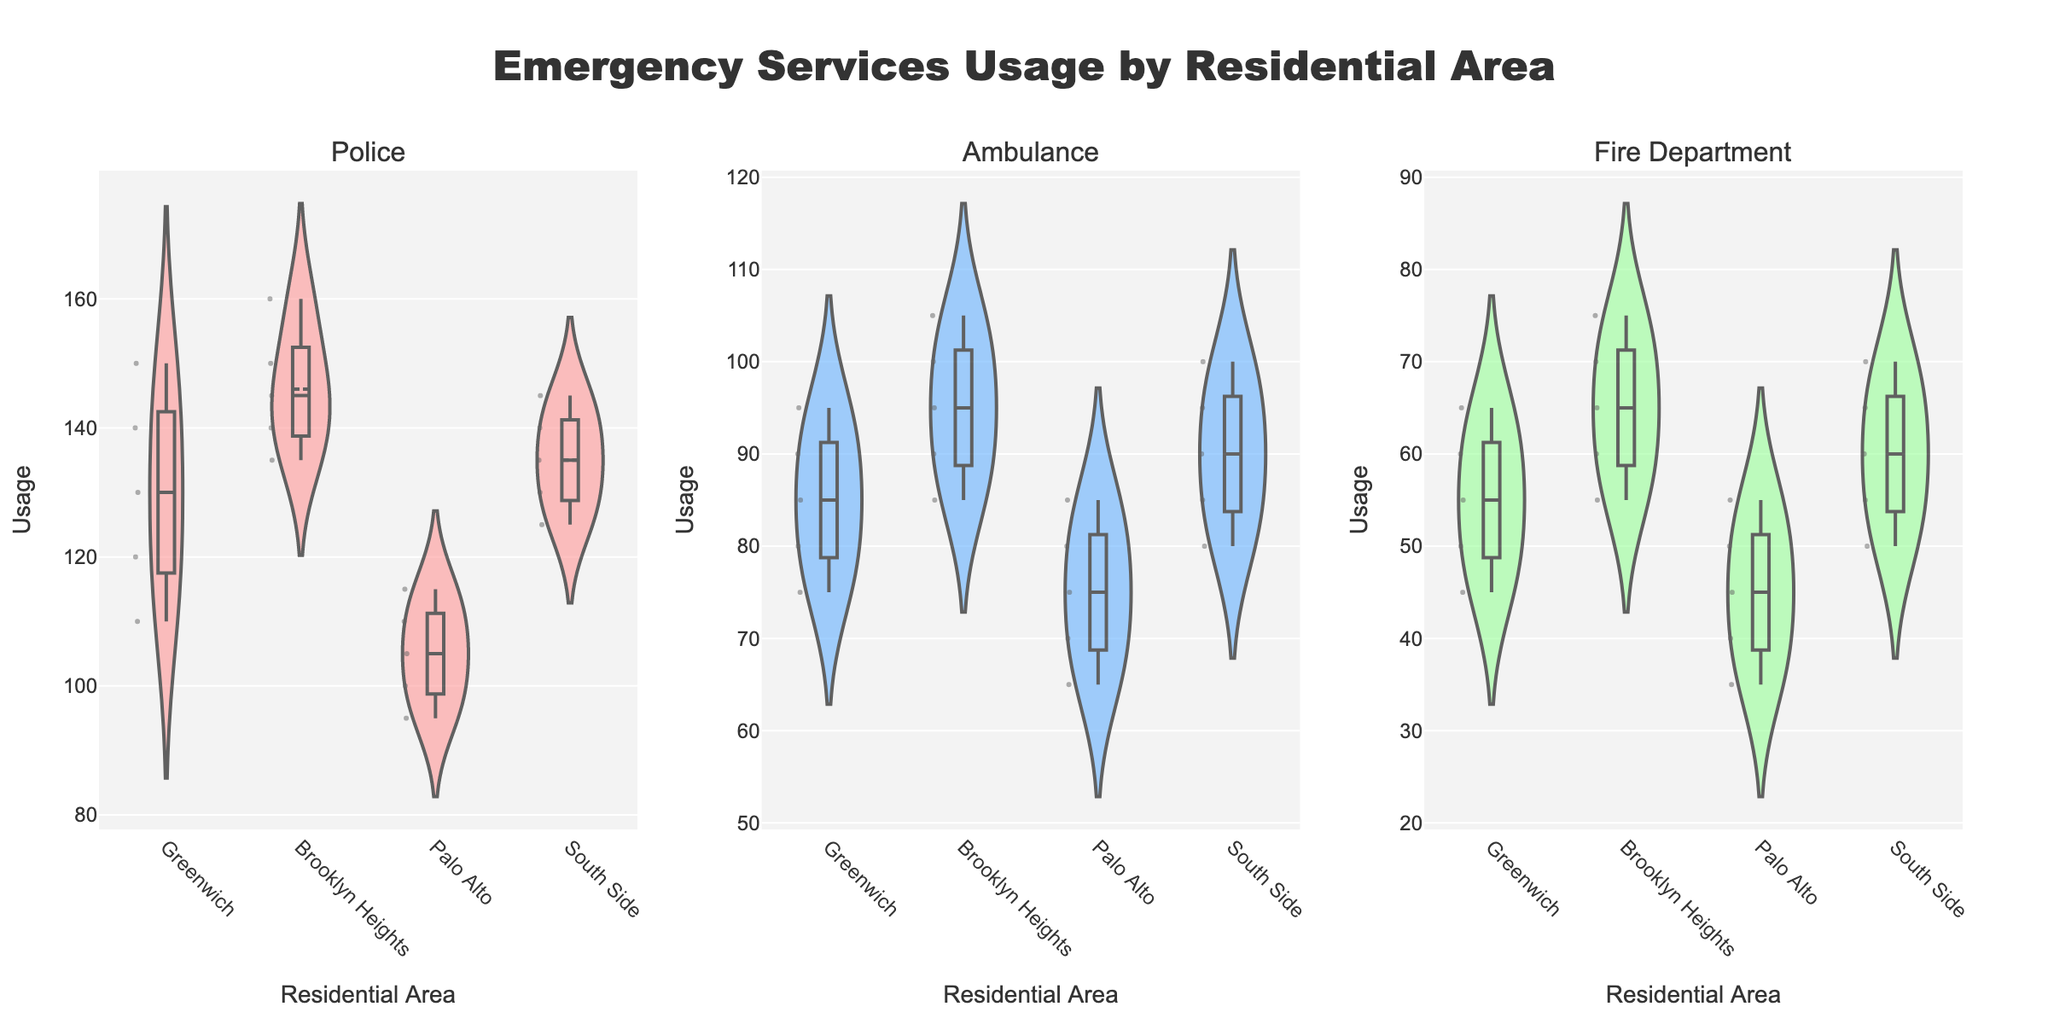What's the title of the figure? The title is usually displayed at the top center of the chart. In this case, it reads "Emergency Services Usage by Residential Area".
Answer: Emergency Services Usage by Residential Area How many subplots are in the figure and what services do they represent? The figure is divided into three subplots, representing Police, Ambulance, and Fire Department services. This is indicated by the subplot titles above each violin chart.
Answer: Three; Police, Ambulance, Fire Department Which residential area has the highest median usage of emergency services in any category? To determine this, look for the area with the highest median line in any of the violin charts. In the "Police" subplot, Brooklyn Heights has the highest median usage.
Answer: Brooklyn Heights Is there a significant difference in the usage of the fire department between Greenwich and Palo Alto? By comparing the medians and spread of the "Fire Department" violin plots for Greenwich and Palo Alto, we can see that usages in both are relatively close but show differences in spread and median.
Answer: Yes Which area shows the most variation in ambulance usage? Variation can be assessed by the width of the violin plot. For "Ambulance" services, Brooklyn Heights appears to have the widest spread in usage.
Answer: Brooklyn Heights What month registers the highest police usage in South Side? By looking into the data visually represented in the violin plot for Police in South Side, you can identify that May shows the highest usage.
Answer: May Which service has the least variation in usage within any single area? Least variation can be identified by the violin plot that is the most narrow. In South Side, the "Fire Department" usage is the least varied.
Answer: Fire Department in South Side Are there any areas where the median usage of ambulance services is higher than the median usage of police services? Compare the median lines within each subplot. None of the areas have a higher median usage for ambulances than for police.
Answer: No What is the average police usage in Palo Alto? The average is calculated by summing all the data points and dividing by the number of data points. (100 + 95 + 105 + 110 + 115) = 525, and 525/5 = 105.
Answer: 105 How does Greenwich's median fire department usage compare to Brooklyn Heights'? Compare the median lines of the "Fire Department" subplot for both areas. Greenwich's median is lower than Brooklyn Heights'.
Answer: Lower 